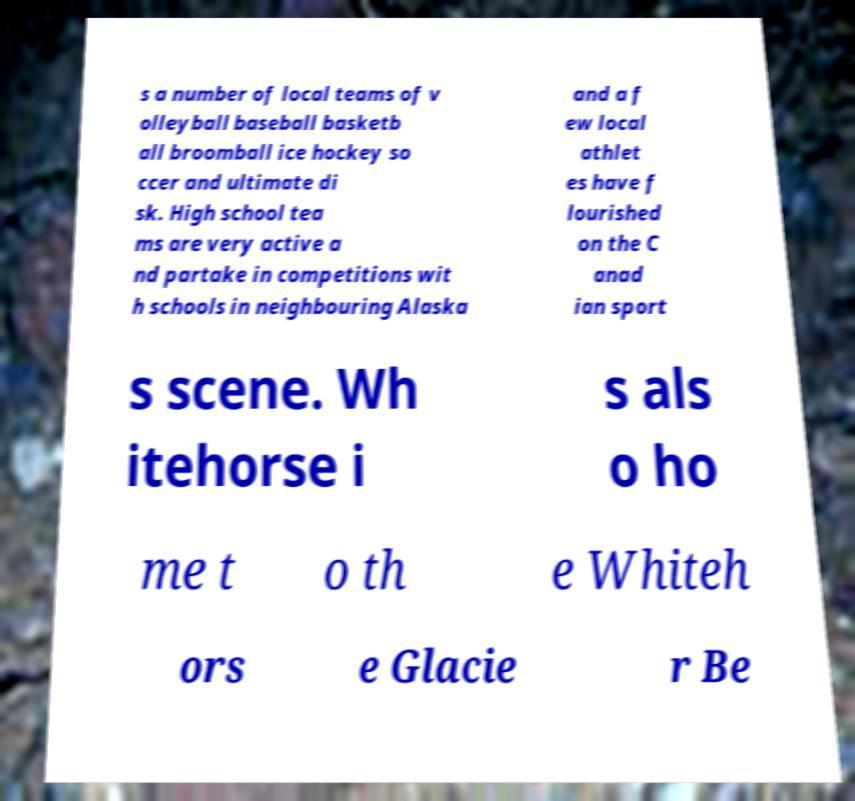Could you assist in decoding the text presented in this image and type it out clearly? s a number of local teams of v olleyball baseball basketb all broomball ice hockey so ccer and ultimate di sk. High school tea ms are very active a nd partake in competitions wit h schools in neighbouring Alaska and a f ew local athlet es have f lourished on the C anad ian sport s scene. Wh itehorse i s als o ho me t o th e Whiteh ors e Glacie r Be 